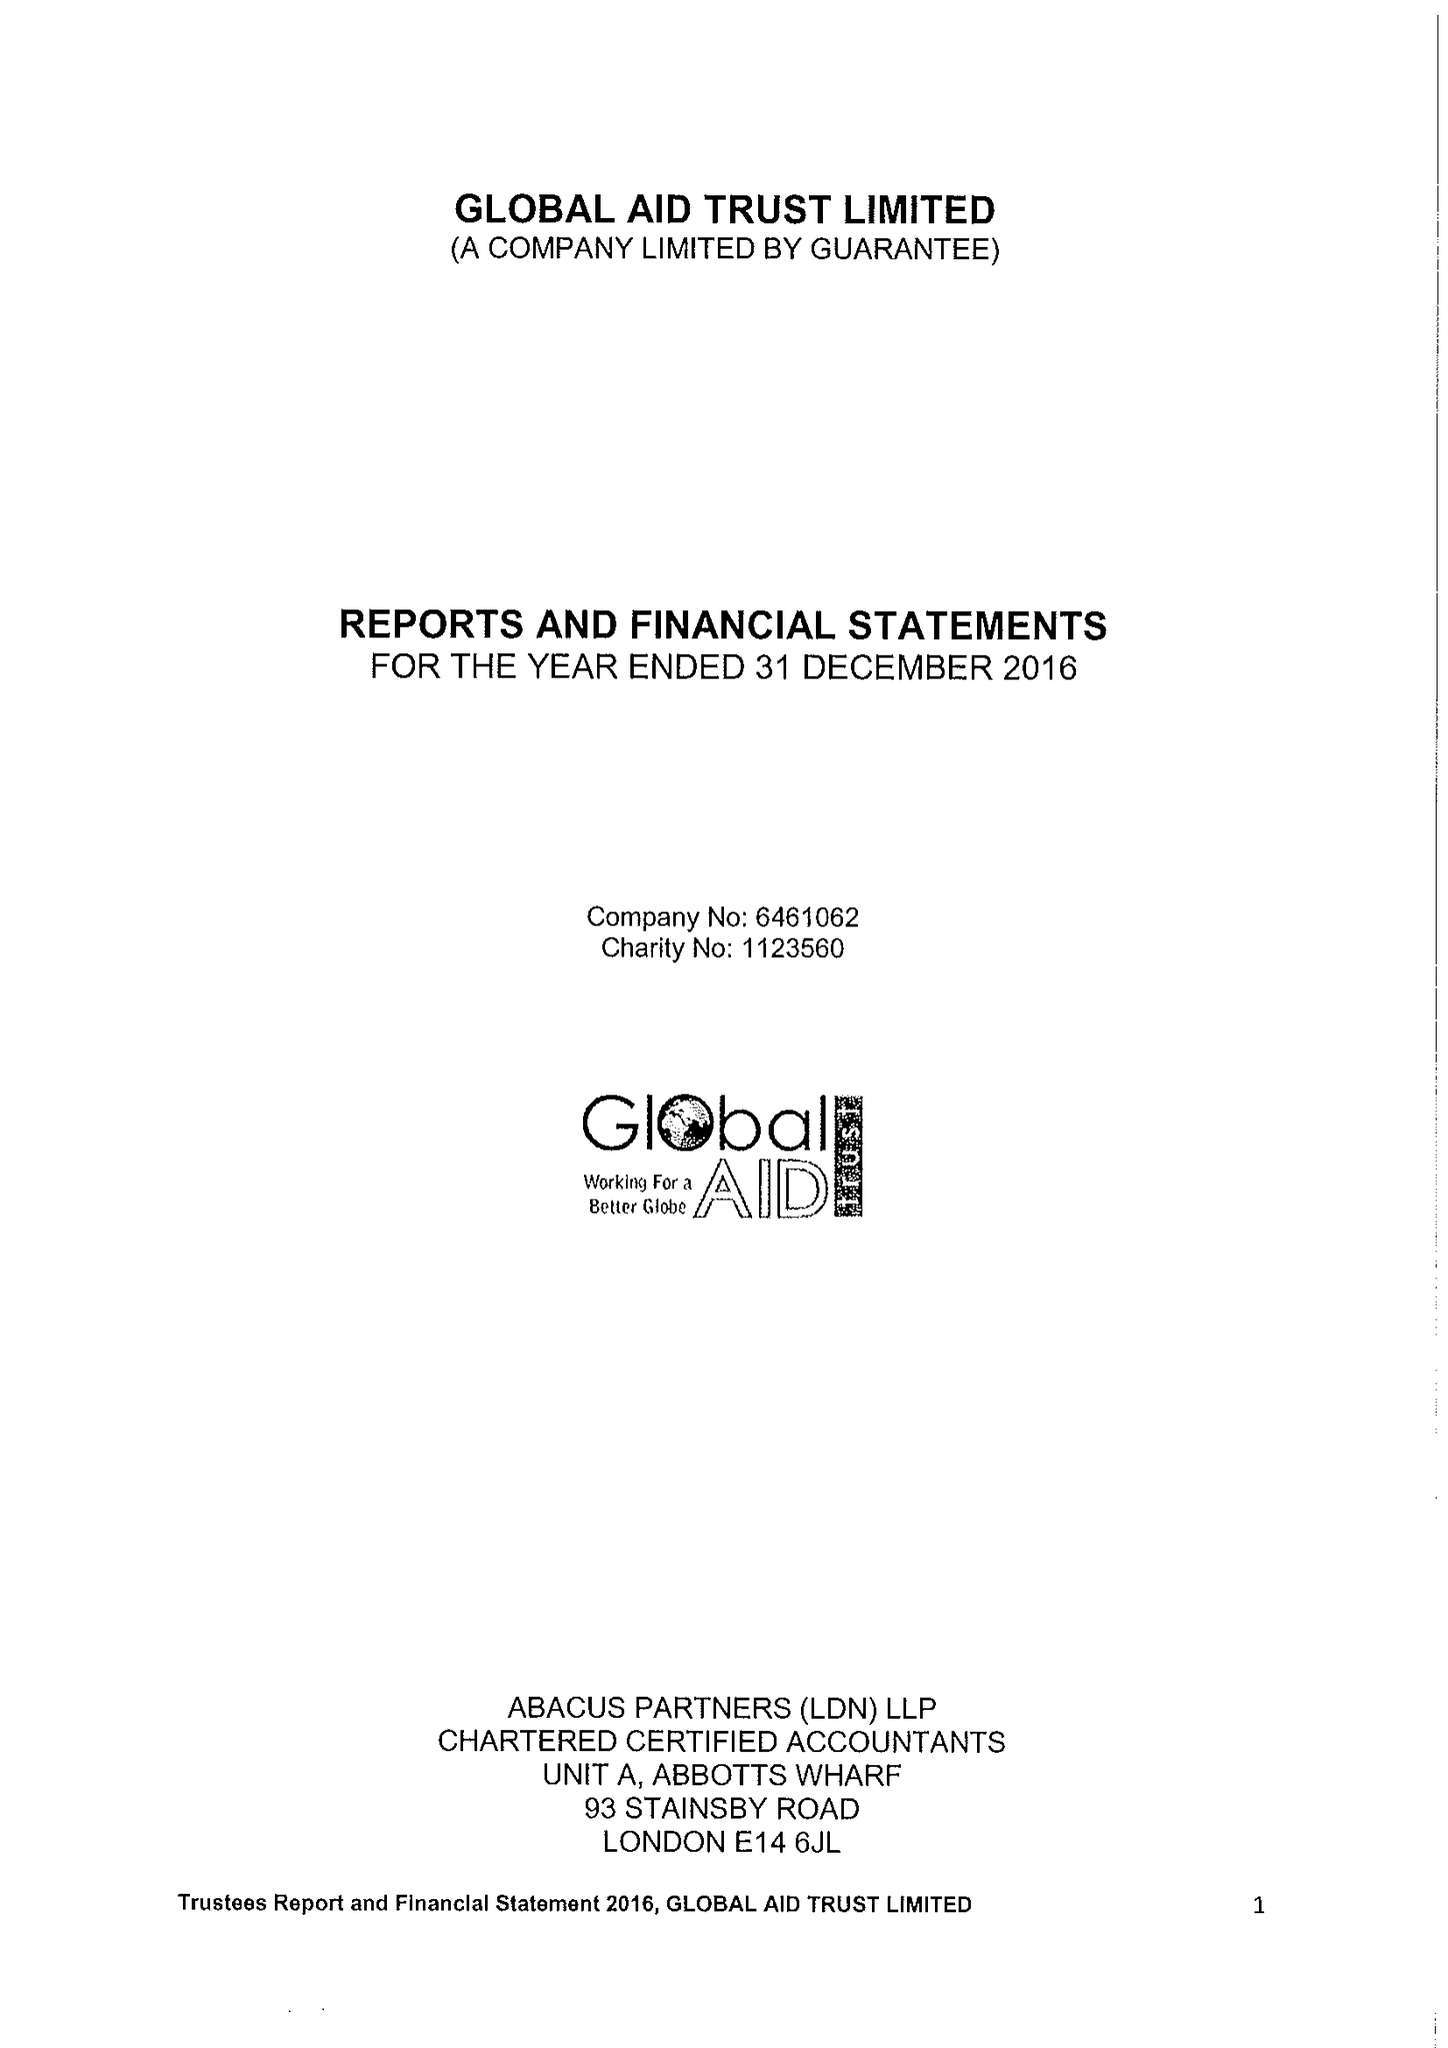What is the value for the address__post_town?
Answer the question using a single word or phrase. LONDON 